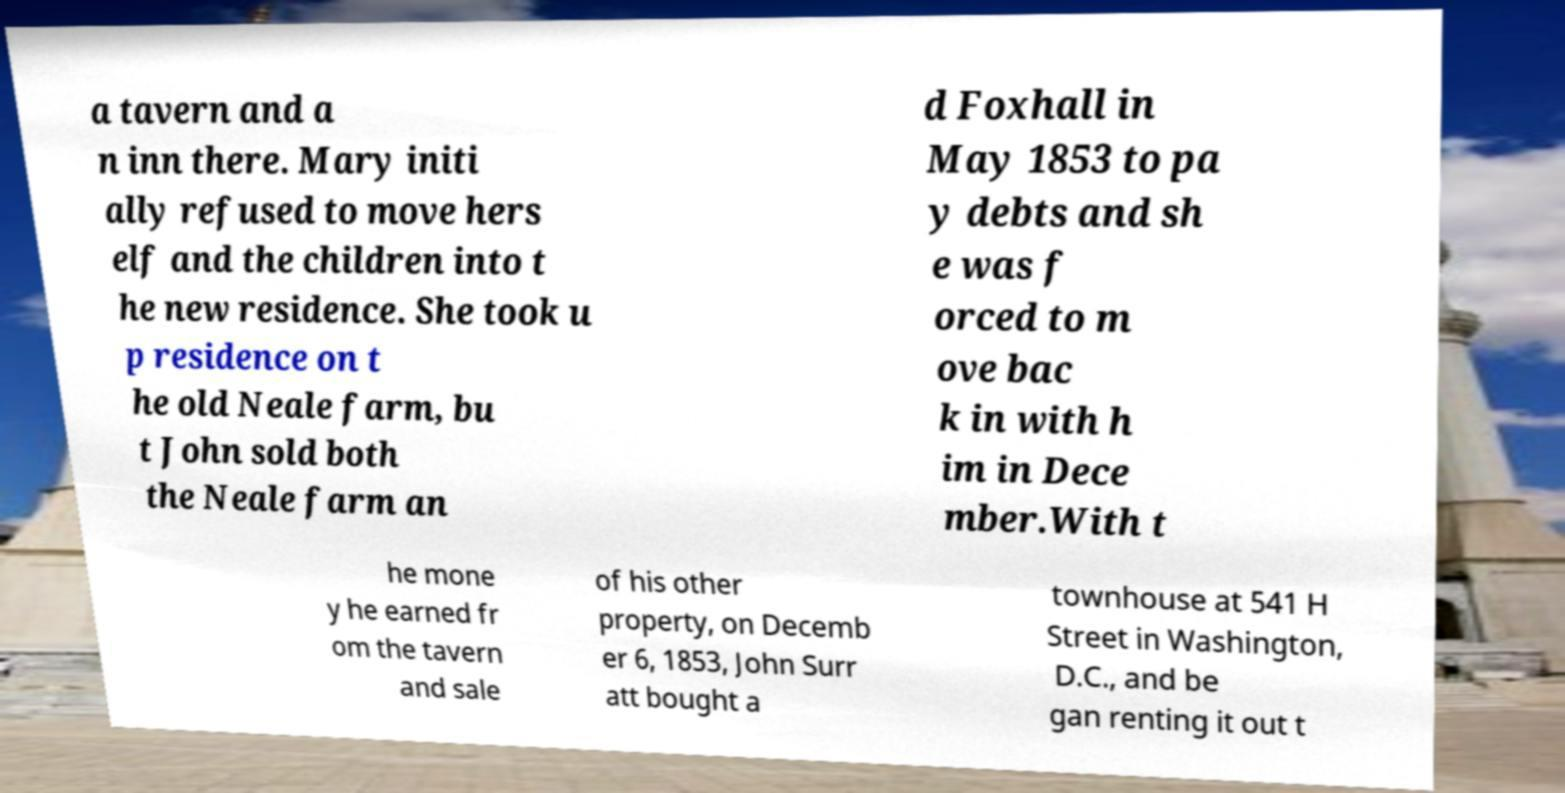There's text embedded in this image that I need extracted. Can you transcribe it verbatim? a tavern and a n inn there. Mary initi ally refused to move hers elf and the children into t he new residence. She took u p residence on t he old Neale farm, bu t John sold both the Neale farm an d Foxhall in May 1853 to pa y debts and sh e was f orced to m ove bac k in with h im in Dece mber.With t he mone y he earned fr om the tavern and sale of his other property, on Decemb er 6, 1853, John Surr att bought a townhouse at 541 H Street in Washington, D.C., and be gan renting it out t 